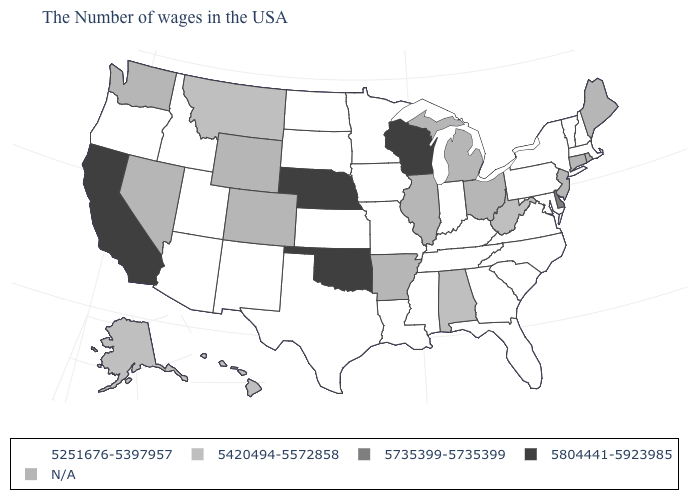What is the value of Nevada?
Keep it brief. N/A. What is the value of New York?
Be succinct. 5251676-5397957. Which states have the lowest value in the USA?
Keep it brief. Massachusetts, New Hampshire, Vermont, New York, Maryland, Pennsylvania, Virginia, North Carolina, South Carolina, Florida, Georgia, Kentucky, Indiana, Tennessee, Mississippi, Louisiana, Missouri, Minnesota, Iowa, Kansas, Texas, South Dakota, North Dakota, New Mexico, Utah, Arizona, Idaho, Oregon. What is the highest value in the USA?
Answer briefly. 5804441-5923985. Among the states that border Idaho , which have the lowest value?
Answer briefly. Utah, Oregon. Name the states that have a value in the range 5735399-5735399?
Short answer required. Delaware. Among the states that border Colorado , which have the highest value?
Quick response, please. Nebraska, Oklahoma. What is the value of Colorado?
Answer briefly. N/A. What is the value of Washington?
Write a very short answer. N/A. What is the value of Iowa?
Give a very brief answer. 5251676-5397957. Name the states that have a value in the range 5804441-5923985?
Short answer required. Wisconsin, Nebraska, Oklahoma, California. What is the value of Kentucky?
Keep it brief. 5251676-5397957. What is the lowest value in states that border Nevada?
Give a very brief answer. 5251676-5397957. Does North Dakota have the lowest value in the MidWest?
Concise answer only. Yes. What is the value of Arkansas?
Concise answer only. N/A. 